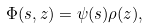Convert formula to latex. <formula><loc_0><loc_0><loc_500><loc_500>\Phi ( s , z ) = \psi ( s ) \rho ( z ) ,</formula> 